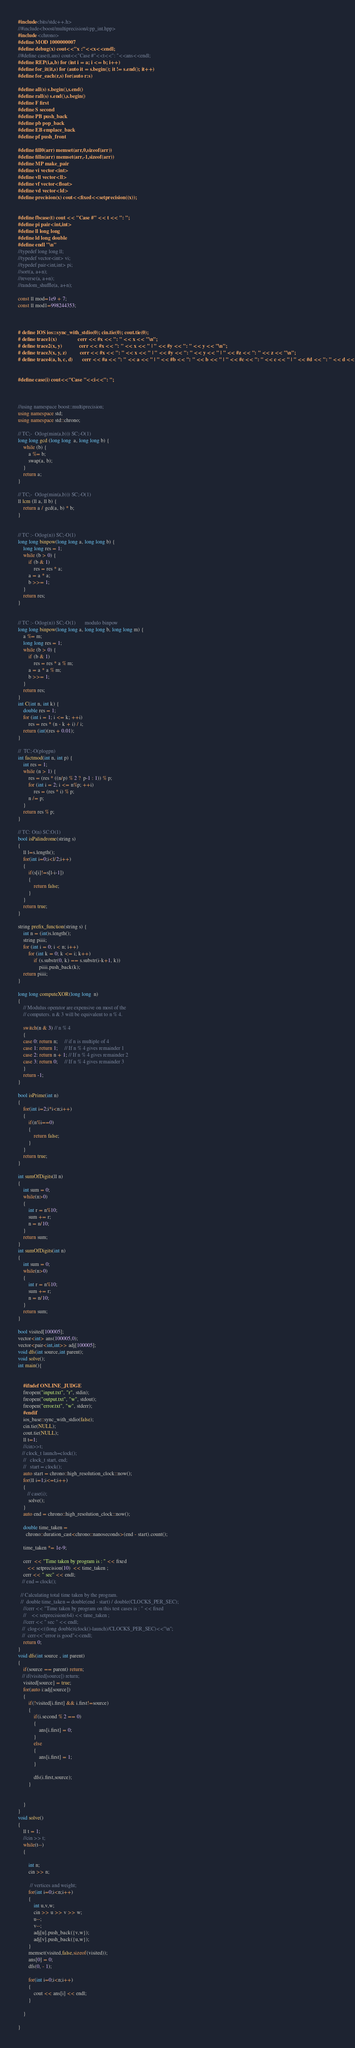Convert code to text. <code><loc_0><loc_0><loc_500><loc_500><_C++_>#include<bits/stdc++.h>
//#include<boost/multiprecision/cpp_int.hpp>
#include <chrono>
#define MOD 1000000007
#define debug(x) cout<<"x :"<<x<<endl;
//#define case(t,ans) cout<<"Case #"<<t<<": "<<ans<<endl;
#define REP(i,a,b) for (int i = a; i <= b; i++)
#define for_it(it,s) for (auto it = s.begin(); it != s.end(); it++)
#define for_each(r,s) for(auto r:s)

#define all(s) s.begin(),s.end()
#define rall(s) s.end(),s.begin()
#define F first
#define S second
#define PB push_back
#define pb pop_back
#define EB emplace_back
#define pf push_front

#define fill0(arr) memset(arr,0,sizeof(arr))
#define filln(arr) memset(arr,-1,sizeof(arr))
#define MP make_pair
#define vi vector<int>
#define vll vector<ll>
#define vf vector<float>
#define vd vector<ld>
#define precision(x) cout<<fixed<<setprecision((x));
 

#define fbcase(t) cout << "Case #" << t << ": ";
#define pi pair<int,int> 
#define ll long long 
#define ld long double
#define endl "\n"
//typedef long long ll;
//typedef vector<int> vi;
//typedef pair<int,int> pi;
//sort(a, a+n);
//reverse(a, a+n);
//random_shuffle(a, a+n);

const ll mod=1e9 + 7;
const ll mod1=998244353;



# define IOS ios::sync_with_stdio(0); cin.tie(0); cout.tie(0);
# define trace1(x)                cerr << #x << ": " << x << "\n";
# define trace2(x, y)             cerr << #x << ": " << x << " | " << #y << ": " << y << "\n";
# define trace3(x, y, z)          cerr << #x << ": " << x << " | " << #y << ": " << y << " | " << #z << ": " << z << "\n";
# define trace4(a, b, c, d)       cerr << #a << ": " << a << " | " << #b << ": " << b << " | " << #c << ": " << c << " | " << #d << ": " << d << "\n";


#define case(i) cout<<"Case "<<i<<": ";



//using namespace boost::multiprecision;
using namespace std;
using namespace std::chrono;

// TC;-  O(log(min(a,b))) SC;-O(1)
long long gcd (long long  a, long long b) {
    while (b) {
        a %= b;
        swap(a, b);
    }
    return a;
}

// TC;-  O(log(min(a,b))) SC;-O(1)
ll lcm (ll a, ll b) {
    return a / gcd(a, b) * b;
} 


// TC :- O(log(n)) SC;-O(1)
long long binpow(long long a, long long b) {
    long long res = 1;
    while (b > 0) {
        if (b & 1)
            res = res * a;
        a = a * a;
        b >>= 1;
    }
    return res;
}


// TC :- O(log(n)) SC;-O(1)       modulo binpow
long long binpow(long long a, long long b, long long m) {
    a %= m;
    long long res = 1;
    while (b > 0) {
        if (b & 1)
            res = res * a % m;
        a = a * a % m;
        b >>= 1;
    }
    return res;
}
int C(int n, int k) {
    double res = 1;
    for (int i = 1; i <= k; ++i)
        res = res * (n - k + i) / i;
    return (int)(res + 0.01);
}

//  TC;-O(plogpn)
int factmod(int n, int p) {
    int res = 1;
    while (n > 1) {
        res = (res * ((n/p) % 2 ?  p-1 : 1)) % p;
        for (int i = 2; i <= n%p; ++i)
            res = (res * i) % p;
        n /= p;
    }
    return res % p;
}

// TC: O(n) SC:O(1)
bool isPalindrome(string s)
{
    ll l=s.length();
    for(int i=0;i<l/2;i++)
    {
        if(s[i]!=s[l-i-1])
        {
            return false;
        }
    }
    return true;
}

string prefix_function(string s) {
    int n = (int)s.length();
    string piiii;
    for (int i = 0; i < n; i++)
        for (int k = 0; k <= i; k++)
            if (s.substr(0, k) == s.substr(i-k+1, k))
                piiii.push_back(k);
    return piiii;
}

long long computeXOR(long long  n) 
{ 
    // Modulus operator are expensive on most of the  
    // computers. n & 3 will be equivalent to n % 4.    
  
    switch(n & 3) // n % 4  
    { 
    case 0: return n;     // if n is multiple of 4 
    case 1: return 1;     // If n % 4 gives remainder 1   
    case 2: return n + 1; // If n % 4 gives remainder 2     
    case 3: return 0;     // If n % 4 gives remainder 3   
    } 
    return -1;
} 
  
bool isPrime(int n)
{
    for(int i=2;i*i<n;i++)
    {
        if(n%i==0)
        {
            return false;
        }
    }
    return true;
}

int sumOfDigits(ll n)
{
    int sum = 0;
    while(n>0)
    {
        int r = n%10;
        sum += r;
        n = n/10;
    }
    return sum;
}
int sumOfDigits(int n)
{
    int sum = 0;
    while(n>0)
    {
        int r = n%10;
        sum += r;
        n = n/10;
    }
    return sum;
}

bool visited[100005];
vector<int> ans(100005,0);
vector<pair<int,int>> adj[100005];
void dfs(int source,int parent);
void solve();
int main(){


    #ifndef ONLINE_JUDGE
    freopen("input.txt", "r", stdin);
    freopen("output.txt", "w", stdout);
    freopen("error.txt", "w", stderr);
    #endif
    ios_base::sync_with_stdio(false);
    cin.tie(NULL);
    cout.tie(NULL);
    ll t=1;
    //cin>>t;
   // clock_t launch=clock();
    //   clock_t start, end;
    //   start = clock();
    auto start = chrono::high_resolution_clock::now();
    for(ll i=1;i<=t;i++)
    {
       // case(i);
        solve();
    }
    auto end = chrono::high_resolution_clock::now();

    double time_taken =  
      chrono::duration_cast<chrono::nanoseconds>(end - start).count(); 
  
    time_taken *= 1e-9; 
  
    cerr  << "Time taken by program is : " << fixed  
       << setprecision(10)  << time_taken ; 
    cerr << " sec" << endl;
   // end = clock();

  // Calculating total time taken by the program. 
  //  double time_taken = double(end - start) / double(CLOCKS_PER_SEC); 
    //cerr << "Time taken by program on this test cases is : " << fixed  
    //    << setprecision(64) << time_taken ; 
    //cerr << " sec " << endl;  
   //  clog<<((long double)(clock()-launch)/CLOCKS_PER_SEC)<<"\n";
   //  cerr<<"error is good"<<endl;
    return 0;
}
void dfs(int source , int parent)
{
    if(source == parent) return;
   // if(visited[source]) return;
    visited[source] = true;
    for(auto i:adj[source])
    {
        if(!visited[i.first] && i.first!=source)
        {
            if(i.second % 2 == 0)
            {
                ans[i.first] = 0;
            }
            else
            {
                ans[i.first] = 1;
            }

            dfs(i.first,source);
        }
        

    }
}
void solve()
{
    ll t = 1;
    //cin >> t;
    while(t--)
    {
        
        int n;
        cin >> n;
        
         // vertices and weight;
        for(int i=0;i<n;i++)
        {
            int u,v,w;
            cin >> u >> v >> w;
            u--;
            v--;
            adj[u].push_back({v,w});
            adj[v].push_back({u,w});
        }
        memset(visited,false,sizeof(visited));
        ans[0] = 0;
        dfs(0, - 1);

        for(int i=0;i<n;i++)
        {
            cout << ans[i] << endl;
        }

    }

}
</code> 